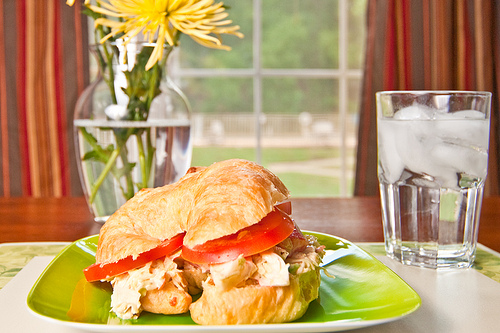If this setting was in a bustling city cafe, how would it look different? In a bustling city cafe, the scene might look slightly different. The background could feature modern decor with sleek tables and high stools, large glass windows showcasing a busy street outside with people passing by and cars honking. The vase with yellow flowers might be replaced with a chic glass bottle containing a single rose or a quirky decorative piece. The croissant sandwich would likely be served on a stylish ceramic plate, and the glass of water might be replaced with a trendy mason jar containing lemon or cucumber infused water. Ambient noise of chatter and background music would add to the vibrant atmosphere. 